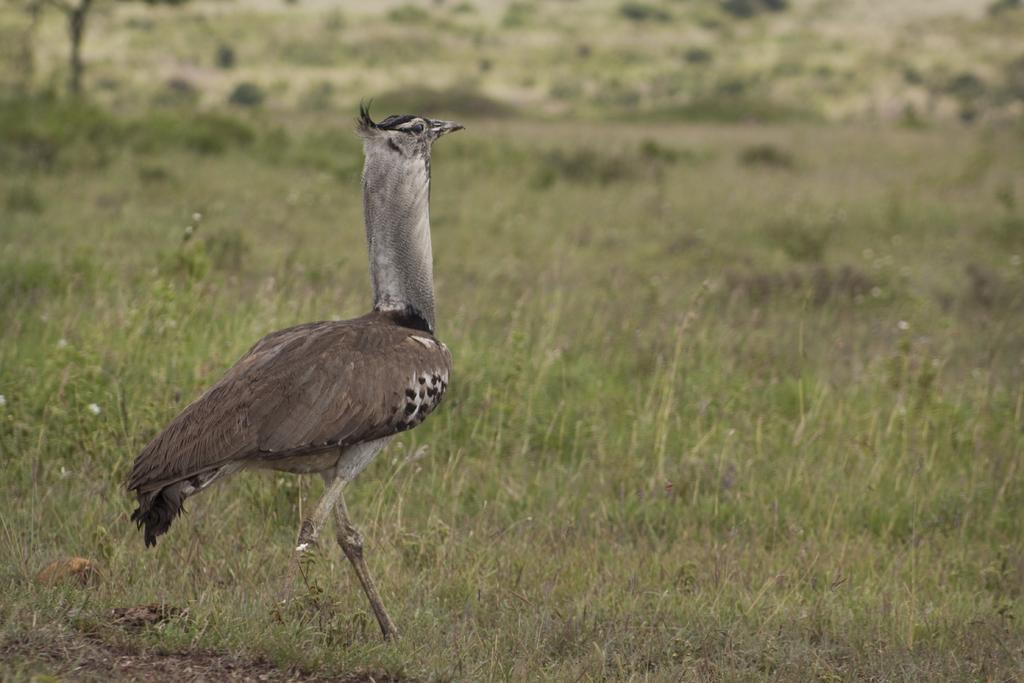What type of animal can be seen in the picture? There is a bird in the picture. What is the name of the bird? The bird's name is hammercop. What type of environment is depicted in the image? The image depicts a dry grassland area. Where is the playground located in the image? There is no playground present in the image; it features a bird in a dry grassland area. What type of material is used to cover the bird's wings? The image does not provide information about the bird's wings or any covering material. --- Facts: 1. There is a person sitting on a bench in the image. 2. The person is reading a book. 3. The bench is located in a park. 4. There are trees in the background of the image. Absurd Topics: dance, ocean, guitar Conversation: What is the person in the image doing? The person is sitting on a bench and reading a book. Where is the bench located? The bench is located in a park. What can be seen in the background of the image? There are trees in the background of the image. Reasoning: Let's think step by step in order to produce the conversation. We start by identifying the main subject in the image, which is the person sitting on the bench. Then, we describe the person's activity, which is reading a book. Next, we provide the location of the bench, which is in a park. Finally, we describe the background of the image, which includes trees. Absurd Question/Answer: What type of dance is the person performing in the image? There is no indication in the image that the person is dancing; they are sitting on a bench and reading a book. Can you see the ocean in the background of the image? No, the image does not depict the ocean; it features a person reading a book in a park with trees in the background. 